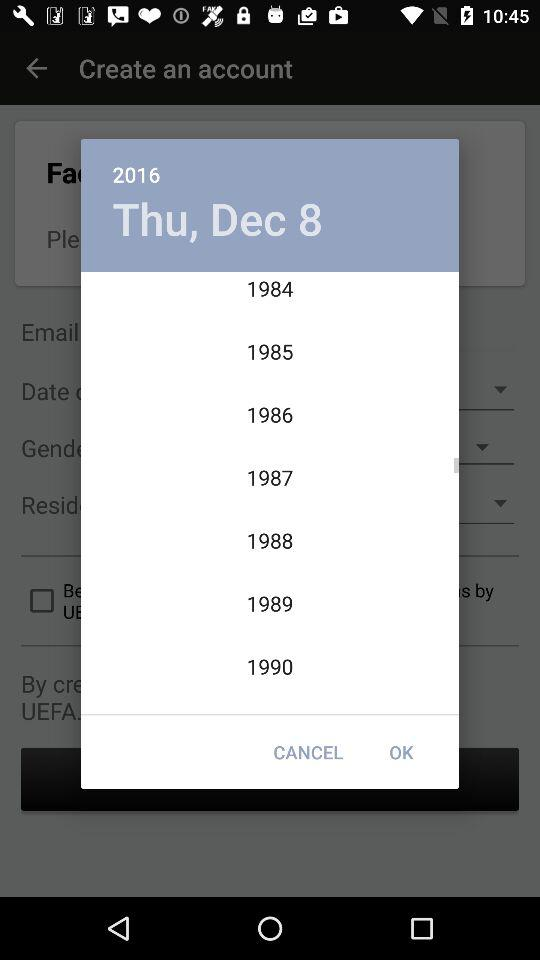Which day falls on December 8, 2016? The day is Thursday. 